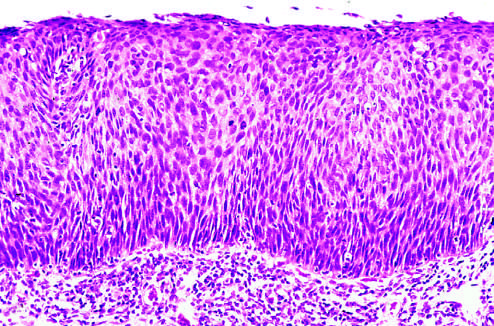s the entire thickness of the epithelium replaced by atypical dysplastic cells?
Answer the question using a single word or phrase. Yes 